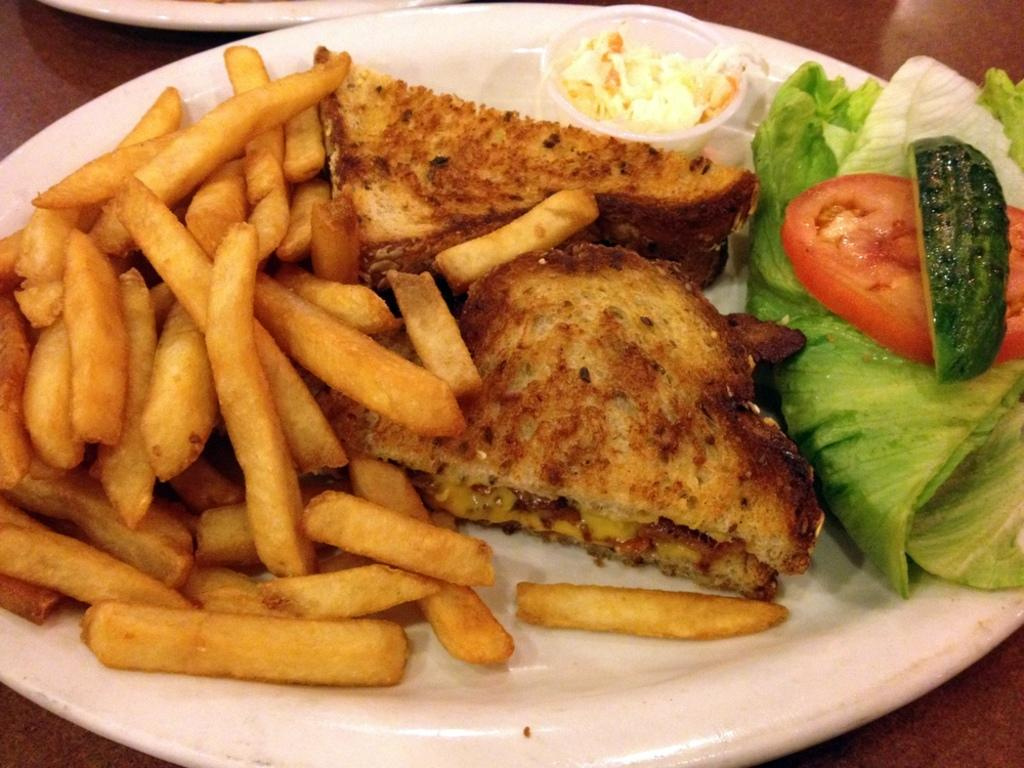What is the main object in the center of the image? There is a plate in the center of the image. What types of food are on the plate? The plate contains french fries and salad. Are there any other food items on the plate? Yes, there are other food items on the plate. What type of bucket is used to serve the salad in the image? There is no bucket present in the image; the salad is served on a plate. How does the curve of the french fries affect their taste in the image? The image does not provide information about the taste or texture of the french fries, so we cannot determine how the curve affects their taste. 